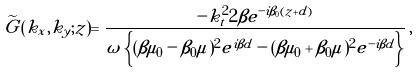<formula> <loc_0><loc_0><loc_500><loc_500>\widetilde { G } ( k _ { x } , k _ { y } ; z ) = \frac { - k _ { t } ^ { 2 } 2 \beta e ^ { - i \beta _ { 0 } ( z + d ) } } { \omega \left \{ ( \beta \mu _ { 0 } - \beta _ { 0 } \mu ) ^ { 2 } e ^ { i \beta d } - ( \beta \mu _ { 0 } + \beta _ { 0 } \mu ) ^ { 2 } e ^ { - i \beta d } \right \} } \, ,</formula> 